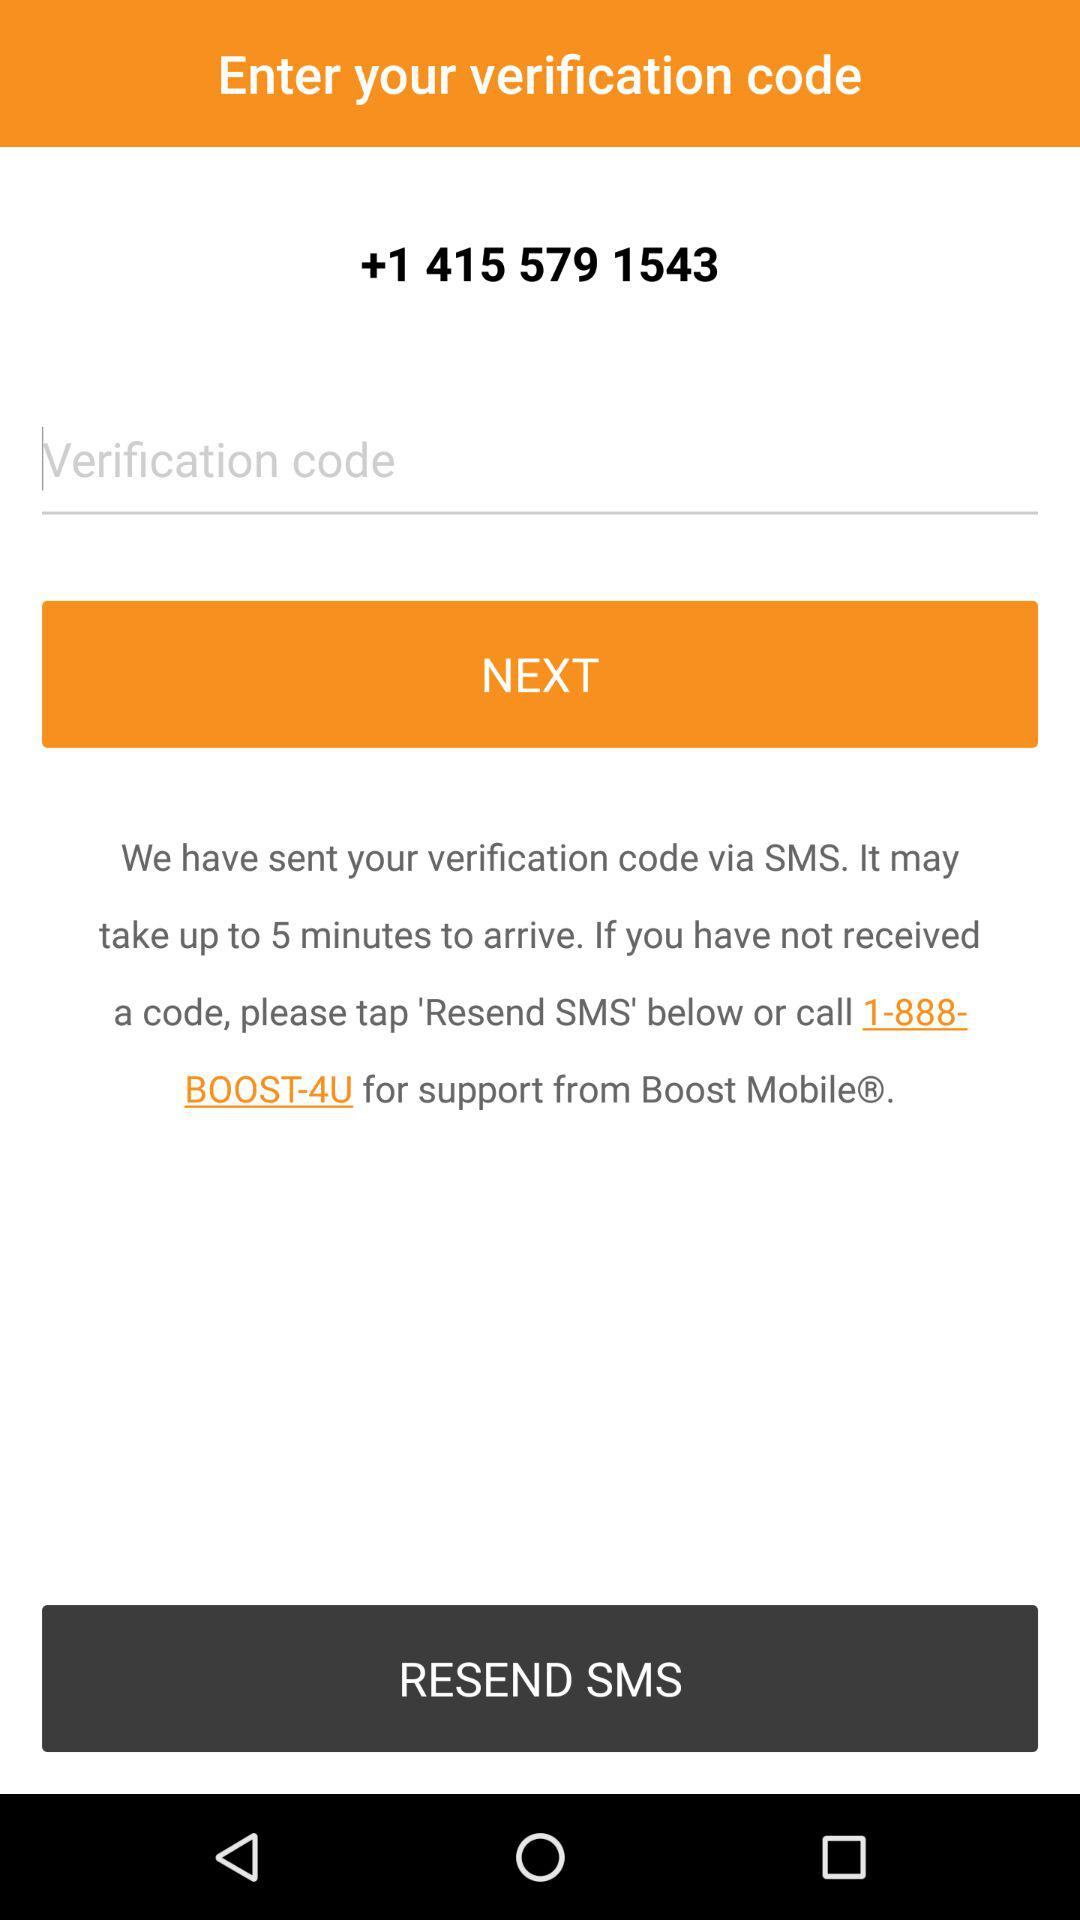On what tab do we need to tap if the verification code is not received? You need to tap "RESEND SMS" if the verification code is not received. 